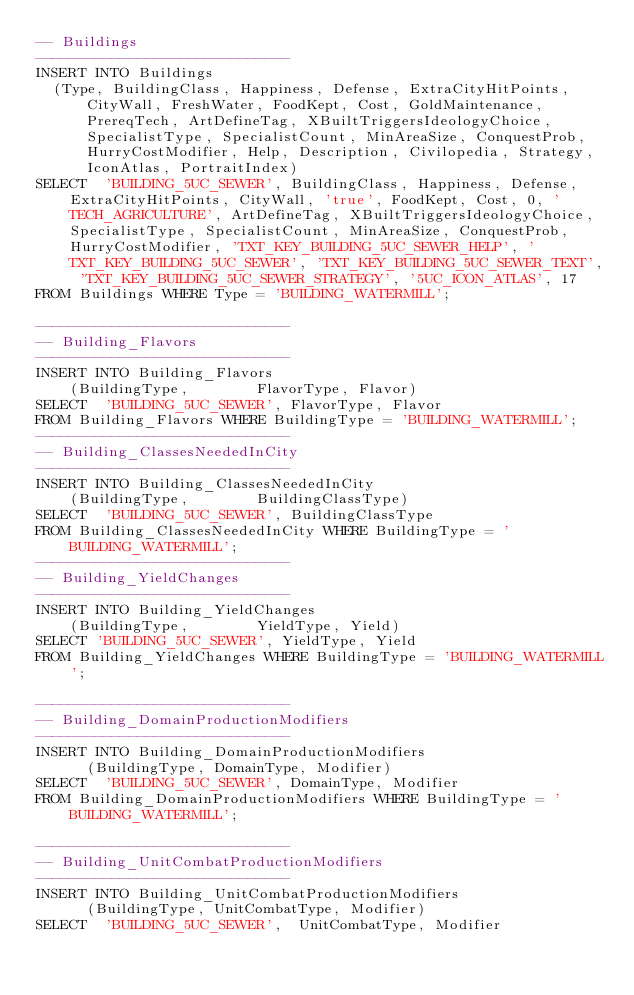<code> <loc_0><loc_0><loc_500><loc_500><_SQL_>-- Buildings
------------------------------	
INSERT INTO Buildings 	
	(Type, BuildingClass, Happiness, Defense, ExtraCityHitPoints, CityWall, FreshWater, FoodKept, Cost, GoldMaintenance, PrereqTech, ArtDefineTag, XBuiltTriggersIdeologyChoice, SpecialistType, SpecialistCount, MinAreaSize, ConquestProb, HurryCostModifier, Help, Description, Civilopedia, Strategy, IconAtlas, PortraitIndex)
SELECT	'BUILDING_5UC_SEWER', BuildingClass, Happiness, Defense, ExtraCityHitPoints, CityWall, 'true', FoodKept, Cost, 0, 'TECH_AGRICULTURE', ArtDefineTag, XBuiltTriggersIdeologyChoice, SpecialistType, SpecialistCount, MinAreaSize, ConquestProb, HurryCostModifier, 'TXT_KEY_BUILDING_5UC_SEWER_HELP', 'TXT_KEY_BUILDING_5UC_SEWER', 'TXT_KEY_BUILDING_5UC_SEWER_TEXT', 'TXT_KEY_BUILDING_5UC_SEWER_STRATEGY', '5UC_ICON_ATLAS', 17
FROM Buildings WHERE Type = 'BUILDING_WATERMILL';

------------------------------
-- Building_Flavors
------------------------------
INSERT INTO Building_Flavors 	
		(BuildingType, 				FlavorType, Flavor)
SELECT	'BUILDING_5UC_SEWER',	FlavorType, Flavor
FROM Building_Flavors WHERE BuildingType = 'BUILDING_WATERMILL';
------------------------------	
-- Building_ClassesNeededInCity
------------------------------		
INSERT INTO Building_ClassesNeededInCity 	
		(BuildingType, 				BuildingClassType)
SELECT	'BUILDING_5UC_SEWER',	BuildingClassType
FROM Building_ClassesNeededInCity WHERE BuildingType = 'BUILDING_WATERMILL';
------------------------------
-- Building_YieldChanges
------------------------------
INSERT INTO Building_YieldChanges 	
		(BuildingType, 				YieldType, Yield)
SELECT 'BUILDING_5UC_SEWER', YieldType, Yield
FROM Building_YieldChanges WHERE BuildingType = 'BUILDING_WATERMILL';

------------------------------
-- Building_DomainProductionModifiers
------------------------------
INSERT INTO Building_DomainProductionModifiers 	
			(BuildingType, DomainType, Modifier)
SELECT	'BUILDING_5UC_SEWER',	DomainType, Modifier
FROM Building_DomainProductionModifiers WHERE BuildingType = 'BUILDING_WATERMILL';

------------------------------	
-- Building_UnitCombatProductionModifiers
------------------------------
INSERT INTO Building_UnitCombatProductionModifiers 	
			(BuildingType, UnitCombatType, Modifier)
SELECT	'BUILDING_5UC_SEWER',	 UnitCombatType, Modifier</code> 